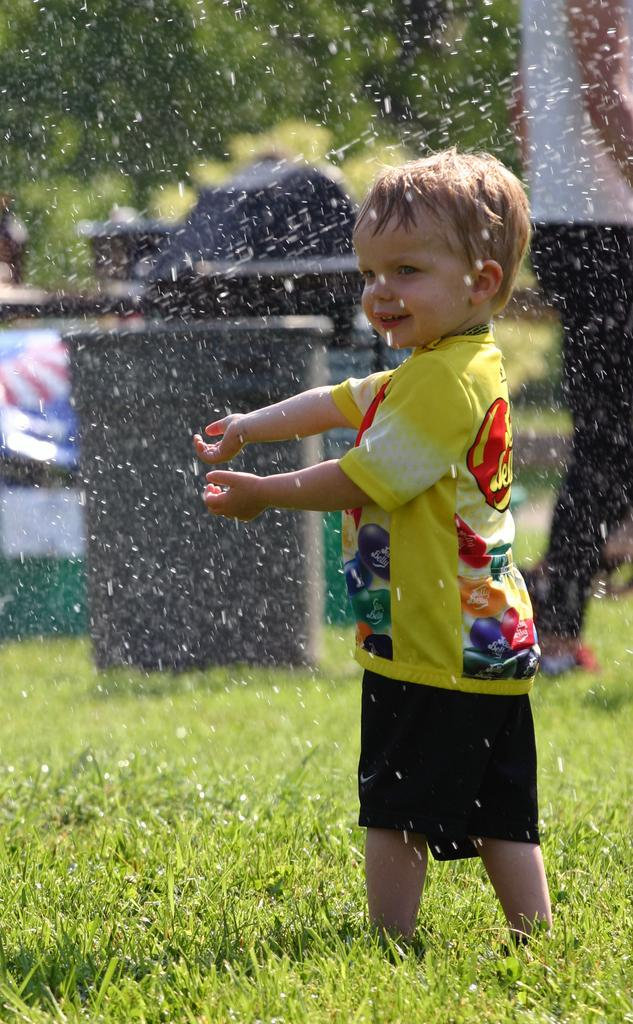How many people are in the image? There are two persons in the image. What is the surface they are standing on? The persons are on grass. What can be seen in the background of the image? There is a box, a fence, some objects, snow, and trees in the background of the image. What type of location might this image be taken in? The image is likely taken in a park. When might this image have been taken? The image is likely taken during the day. What type of rhythm can be heard in the background of the image? There is no audible rhythm present in the image, as it is a still photograph. 